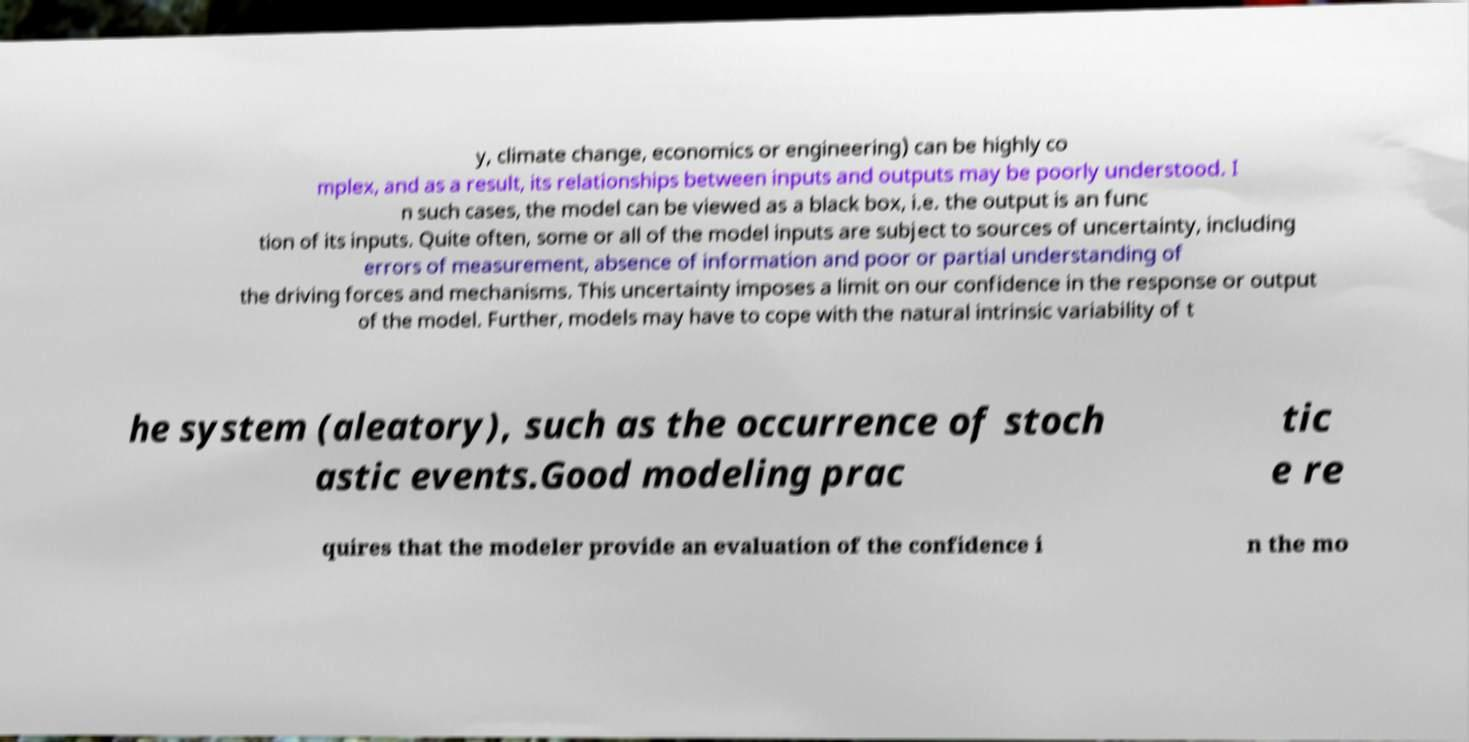Can you read and provide the text displayed in the image?This photo seems to have some interesting text. Can you extract and type it out for me? y, climate change, economics or engineering) can be highly co mplex, and as a result, its relationships between inputs and outputs may be poorly understood. I n such cases, the model can be viewed as a black box, i.e. the output is an func tion of its inputs. Quite often, some or all of the model inputs are subject to sources of uncertainty, including errors of measurement, absence of information and poor or partial understanding of the driving forces and mechanisms. This uncertainty imposes a limit on our confidence in the response or output of the model. Further, models may have to cope with the natural intrinsic variability of t he system (aleatory), such as the occurrence of stoch astic events.Good modeling prac tic e re quires that the modeler provide an evaluation of the confidence i n the mo 